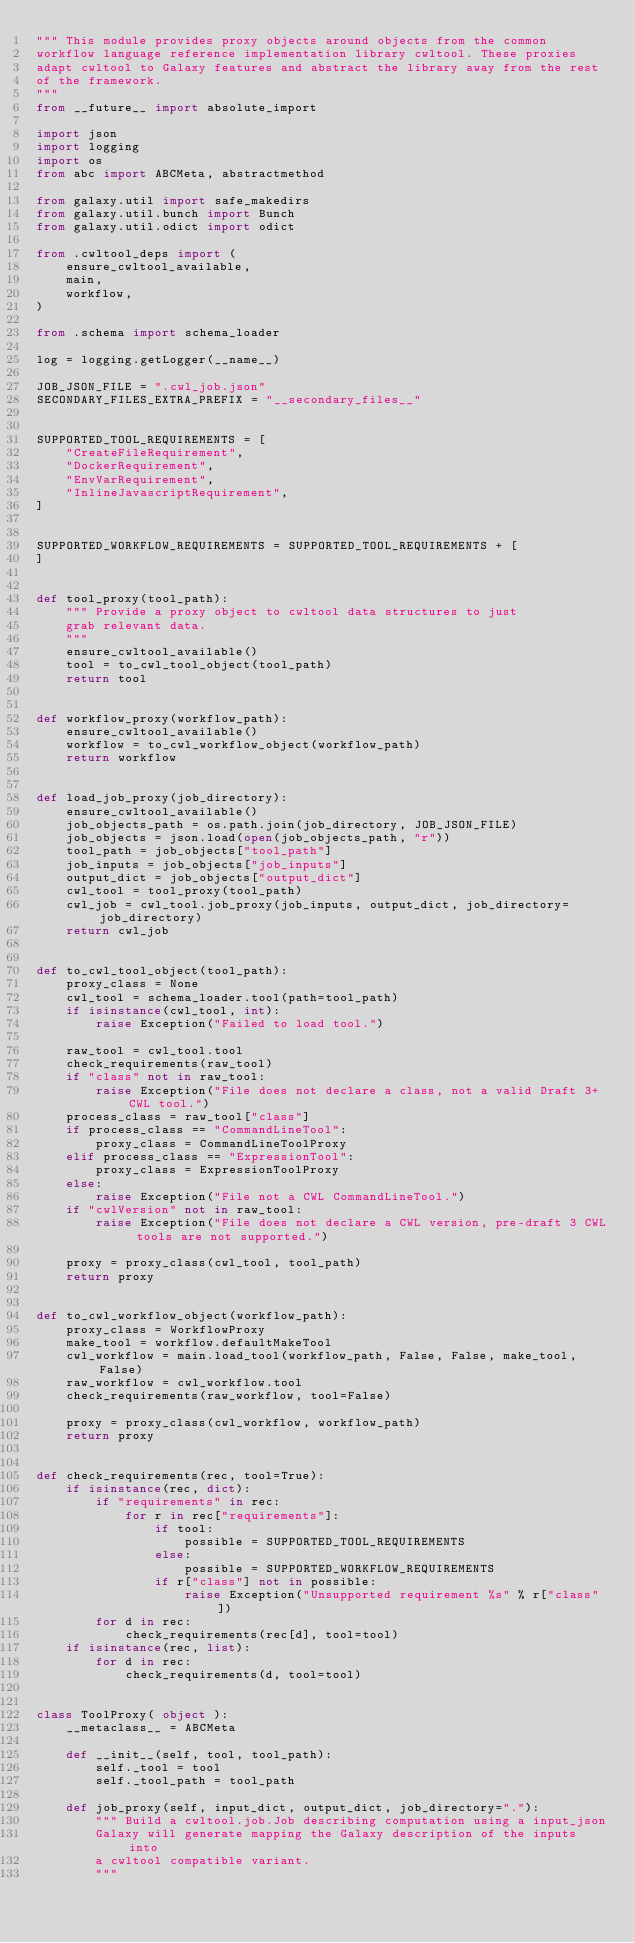Convert code to text. <code><loc_0><loc_0><loc_500><loc_500><_Python_>""" This module provides proxy objects around objects from the common
workflow language reference implementation library cwltool. These proxies
adapt cwltool to Galaxy features and abstract the library away from the rest
of the framework.
"""
from __future__ import absolute_import

import json
import logging
import os
from abc import ABCMeta, abstractmethod

from galaxy.util import safe_makedirs
from galaxy.util.bunch import Bunch
from galaxy.util.odict import odict

from .cwltool_deps import (
    ensure_cwltool_available,
    main,
    workflow,
)

from .schema import schema_loader

log = logging.getLogger(__name__)

JOB_JSON_FILE = ".cwl_job.json"
SECONDARY_FILES_EXTRA_PREFIX = "__secondary_files__"


SUPPORTED_TOOL_REQUIREMENTS = [
    "CreateFileRequirement",
    "DockerRequirement",
    "EnvVarRequirement",
    "InlineJavascriptRequirement",
]


SUPPORTED_WORKFLOW_REQUIREMENTS = SUPPORTED_TOOL_REQUIREMENTS + [
]


def tool_proxy(tool_path):
    """ Provide a proxy object to cwltool data structures to just
    grab relevant data.
    """
    ensure_cwltool_available()
    tool = to_cwl_tool_object(tool_path)
    return tool


def workflow_proxy(workflow_path):
    ensure_cwltool_available()
    workflow = to_cwl_workflow_object(workflow_path)
    return workflow


def load_job_proxy(job_directory):
    ensure_cwltool_available()
    job_objects_path = os.path.join(job_directory, JOB_JSON_FILE)
    job_objects = json.load(open(job_objects_path, "r"))
    tool_path = job_objects["tool_path"]
    job_inputs = job_objects["job_inputs"]
    output_dict = job_objects["output_dict"]
    cwl_tool = tool_proxy(tool_path)
    cwl_job = cwl_tool.job_proxy(job_inputs, output_dict, job_directory=job_directory)
    return cwl_job


def to_cwl_tool_object(tool_path):
    proxy_class = None
    cwl_tool = schema_loader.tool(path=tool_path)
    if isinstance(cwl_tool, int):
        raise Exception("Failed to load tool.")

    raw_tool = cwl_tool.tool
    check_requirements(raw_tool)
    if "class" not in raw_tool:
        raise Exception("File does not declare a class, not a valid Draft 3+ CWL tool.")
    process_class = raw_tool["class"]
    if process_class == "CommandLineTool":
        proxy_class = CommandLineToolProxy
    elif process_class == "ExpressionTool":
        proxy_class = ExpressionToolProxy
    else:
        raise Exception("File not a CWL CommandLineTool.")
    if "cwlVersion" not in raw_tool:
        raise Exception("File does not declare a CWL version, pre-draft 3 CWL tools are not supported.")

    proxy = proxy_class(cwl_tool, tool_path)
    return proxy


def to_cwl_workflow_object(workflow_path):
    proxy_class = WorkflowProxy
    make_tool = workflow.defaultMakeTool
    cwl_workflow = main.load_tool(workflow_path, False, False, make_tool, False)
    raw_workflow = cwl_workflow.tool
    check_requirements(raw_workflow, tool=False)

    proxy = proxy_class(cwl_workflow, workflow_path)
    return proxy


def check_requirements(rec, tool=True):
    if isinstance(rec, dict):
        if "requirements" in rec:
            for r in rec["requirements"]:
                if tool:
                    possible = SUPPORTED_TOOL_REQUIREMENTS
                else:
                    possible = SUPPORTED_WORKFLOW_REQUIREMENTS
                if r["class"] not in possible:
                    raise Exception("Unsupported requirement %s" % r["class"])
        for d in rec:
            check_requirements(rec[d], tool=tool)
    if isinstance(rec, list):
        for d in rec:
            check_requirements(d, tool=tool)


class ToolProxy( object ):
    __metaclass__ = ABCMeta

    def __init__(self, tool, tool_path):
        self._tool = tool
        self._tool_path = tool_path

    def job_proxy(self, input_dict, output_dict, job_directory="."):
        """ Build a cwltool.job.Job describing computation using a input_json
        Galaxy will generate mapping the Galaxy description of the inputs into
        a cwltool compatible variant.
        """</code> 